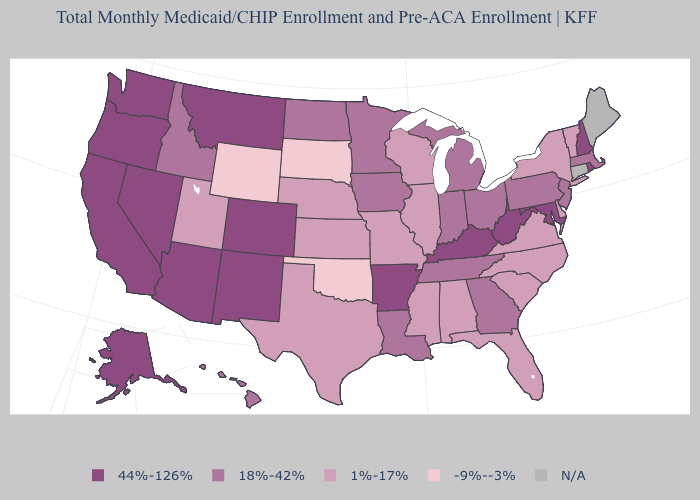Which states have the lowest value in the West?
Quick response, please. Wyoming. Which states have the lowest value in the USA?
Concise answer only. Oklahoma, South Dakota, Wyoming. Name the states that have a value in the range 1%-17%?
Give a very brief answer. Alabama, Delaware, Florida, Illinois, Kansas, Mississippi, Missouri, Nebraska, New York, North Carolina, South Carolina, Texas, Utah, Vermont, Virginia, Wisconsin. Name the states that have a value in the range 44%-126%?
Be succinct. Alaska, Arizona, Arkansas, California, Colorado, Kentucky, Maryland, Montana, Nevada, New Hampshire, New Mexico, Oregon, Rhode Island, Washington, West Virginia. What is the highest value in states that border New Jersey?
Write a very short answer. 18%-42%. What is the value of Mississippi?
Give a very brief answer. 1%-17%. Which states have the lowest value in the South?
Answer briefly. Oklahoma. What is the value of Wyoming?
Answer briefly. -9%--3%. Does Texas have the highest value in the South?
Keep it brief. No. What is the lowest value in states that border Alabama?
Answer briefly. 1%-17%. What is the value of Kentucky?
Keep it brief. 44%-126%. What is the lowest value in the West?
Write a very short answer. -9%--3%. What is the highest value in the USA?
Concise answer only. 44%-126%. 